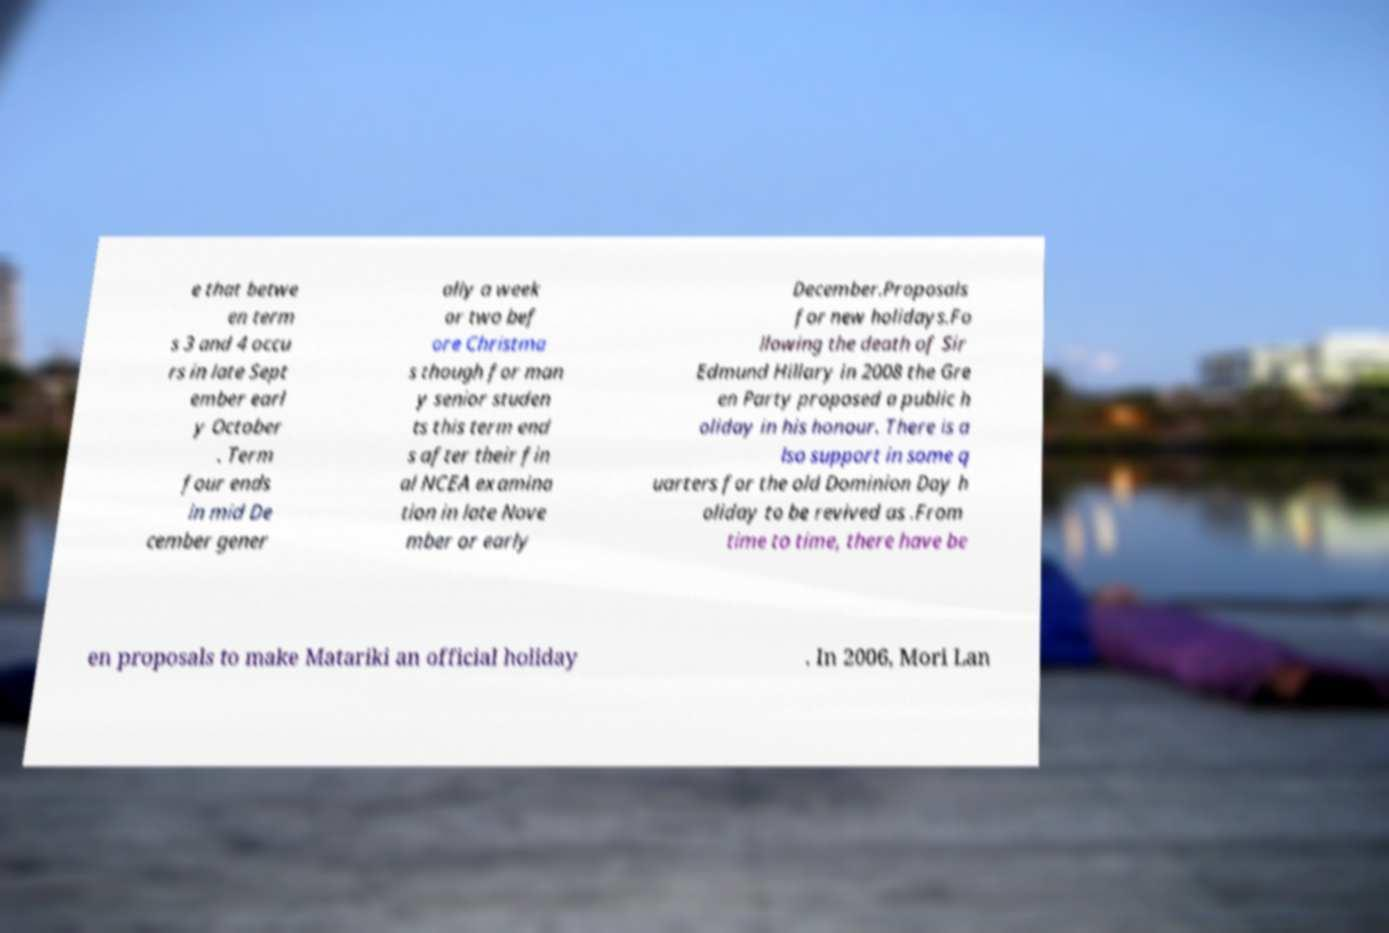Can you accurately transcribe the text from the provided image for me? e that betwe en term s 3 and 4 occu rs in late Sept ember earl y October . Term four ends in mid De cember gener ally a week or two bef ore Christma s though for man y senior studen ts this term end s after their fin al NCEA examina tion in late Nove mber or early December.Proposals for new holidays.Fo llowing the death of Sir Edmund Hillary in 2008 the Gre en Party proposed a public h oliday in his honour. There is a lso support in some q uarters for the old Dominion Day h oliday to be revived as .From time to time, there have be en proposals to make Matariki an official holiday . In 2006, Mori Lan 